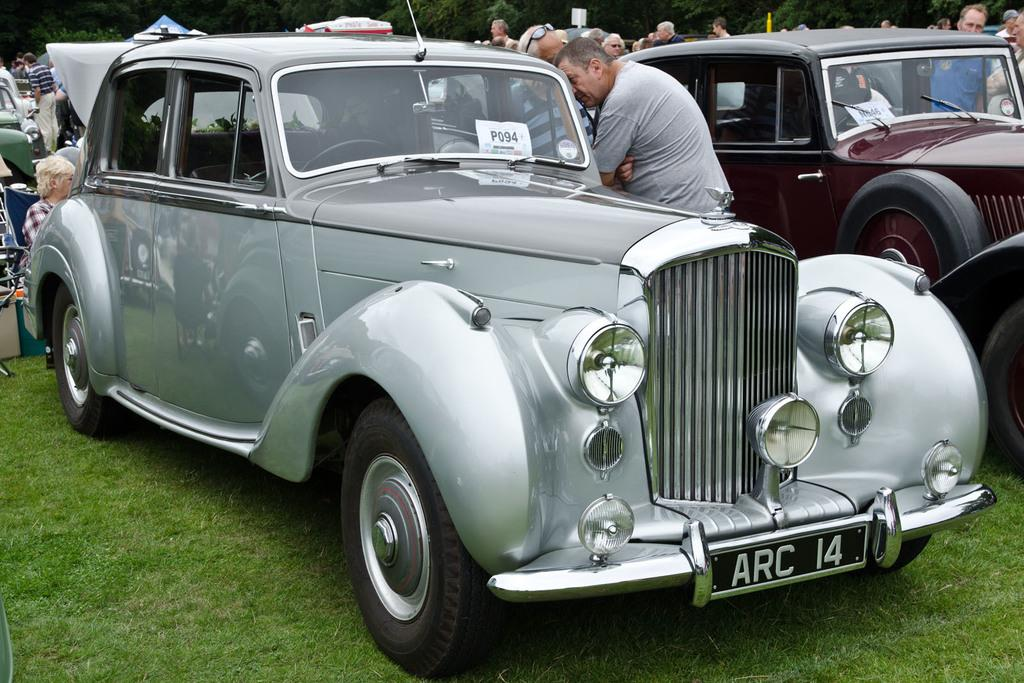What types of objects are present in the image? There are vehicles in the image. What can be seen in the background of the image? In the background, there are people, trees, and other objects. What type of vegetation is visible in the image? Grass is visible in the image. Reasoning: Let' Let's think step by step in order to produce the conversation. We start by identifying the main subject of the image, which are the vehicles. Then, we expand the conversation to include the background of the image, mentioning the presence of people, trees, and other objects. Finally, we describe the type of vegetation visible in the image, which is grass. Absurd Question/Answer: What type of spoon can be seen in the hands of the people in the image? There are no spoons visible in the image, as the people in the background are not holding any objects. 